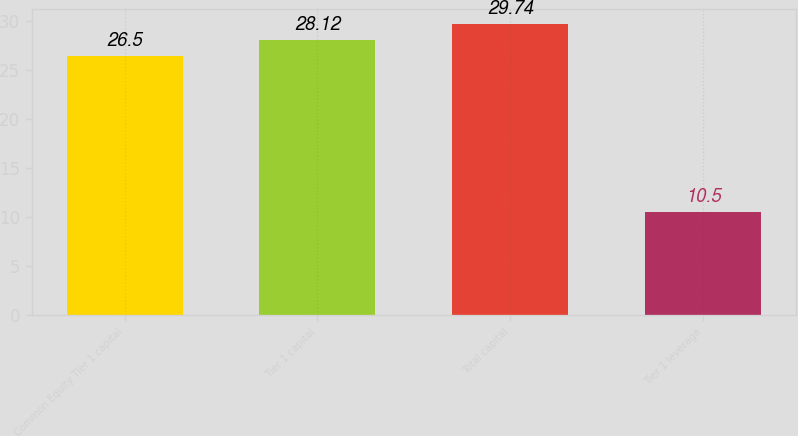Convert chart. <chart><loc_0><loc_0><loc_500><loc_500><bar_chart><fcel>Common Equity Tier 1 capital<fcel>Tier 1 capital<fcel>Total capital<fcel>Tier 1 leverage<nl><fcel>26.5<fcel>28.12<fcel>29.74<fcel>10.5<nl></chart> 